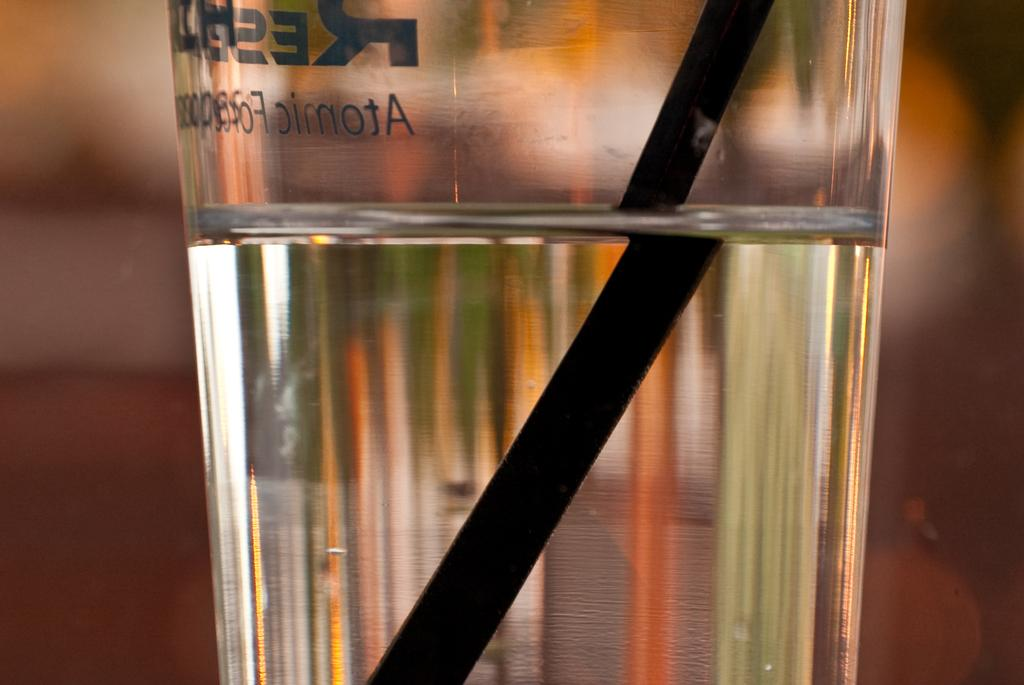<image>
Render a clear and concise summary of the photo. A glass with a straw and writing that says Atomic 